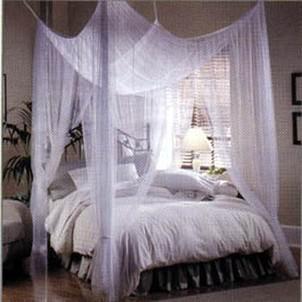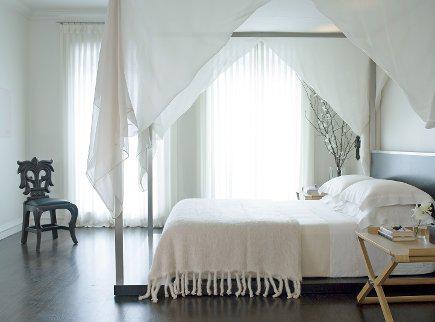The first image is the image on the left, the second image is the image on the right. Examine the images to the left and right. Is the description "The bed on the right is draped by a canopy that descends from a centrally suspended cone shape." accurate? Answer yes or no. No. 